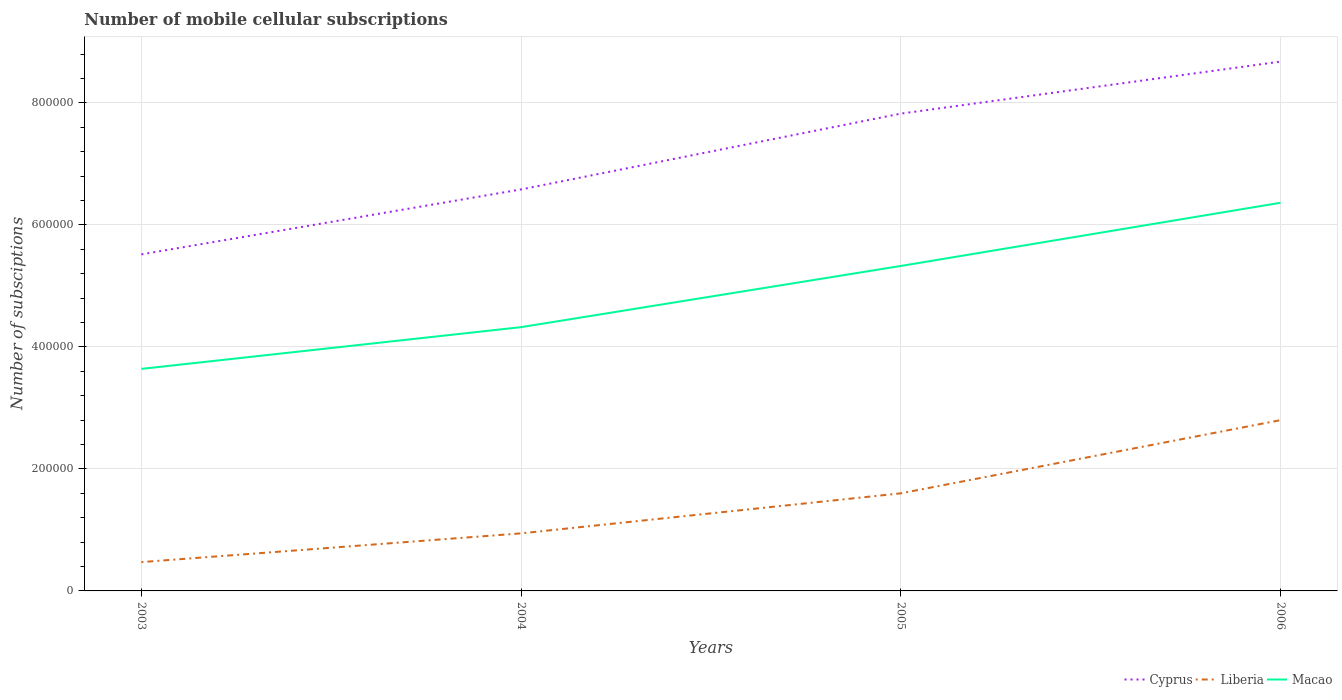How many different coloured lines are there?
Offer a very short reply. 3. Does the line corresponding to Cyprus intersect with the line corresponding to Macao?
Provide a succinct answer. No. Is the number of lines equal to the number of legend labels?
Give a very brief answer. Yes. Across all years, what is the maximum number of mobile cellular subscriptions in Cyprus?
Provide a short and direct response. 5.52e+05. In which year was the number of mobile cellular subscriptions in Macao maximum?
Make the answer very short. 2003. What is the total number of mobile cellular subscriptions in Liberia in the graph?
Give a very brief answer. -4.71e+04. What is the difference between the highest and the second highest number of mobile cellular subscriptions in Liberia?
Keep it short and to the point. 2.33e+05. What is the difference between the highest and the lowest number of mobile cellular subscriptions in Liberia?
Your response must be concise. 2. How many lines are there?
Provide a succinct answer. 3. How many years are there in the graph?
Keep it short and to the point. 4. Are the values on the major ticks of Y-axis written in scientific E-notation?
Your response must be concise. No. Does the graph contain any zero values?
Your answer should be compact. No. How many legend labels are there?
Your answer should be compact. 3. How are the legend labels stacked?
Your answer should be compact. Horizontal. What is the title of the graph?
Your answer should be very brief. Number of mobile cellular subscriptions. What is the label or title of the Y-axis?
Your answer should be very brief. Number of subsciptions. What is the Number of subsciptions of Cyprus in 2003?
Provide a succinct answer. 5.52e+05. What is the Number of subsciptions in Liberia in 2003?
Ensure brevity in your answer.  4.72e+04. What is the Number of subsciptions in Macao in 2003?
Provide a succinct answer. 3.64e+05. What is the Number of subsciptions of Cyprus in 2004?
Keep it short and to the point. 6.58e+05. What is the Number of subsciptions of Liberia in 2004?
Provide a succinct answer. 9.44e+04. What is the Number of subsciptions of Macao in 2004?
Your response must be concise. 4.32e+05. What is the Number of subsciptions of Cyprus in 2005?
Ensure brevity in your answer.  7.83e+05. What is the Number of subsciptions of Macao in 2005?
Your answer should be very brief. 5.33e+05. What is the Number of subsciptions of Cyprus in 2006?
Ensure brevity in your answer.  8.68e+05. What is the Number of subsciptions in Macao in 2006?
Your response must be concise. 6.36e+05. Across all years, what is the maximum Number of subsciptions of Cyprus?
Your answer should be compact. 8.68e+05. Across all years, what is the maximum Number of subsciptions of Liberia?
Your answer should be compact. 2.80e+05. Across all years, what is the maximum Number of subsciptions in Macao?
Make the answer very short. 6.36e+05. Across all years, what is the minimum Number of subsciptions in Cyprus?
Make the answer very short. 5.52e+05. Across all years, what is the minimum Number of subsciptions of Liberia?
Provide a succinct answer. 4.72e+04. Across all years, what is the minimum Number of subsciptions in Macao?
Keep it short and to the point. 3.64e+05. What is the total Number of subsciptions in Cyprus in the graph?
Make the answer very short. 2.86e+06. What is the total Number of subsciptions in Liberia in the graph?
Make the answer very short. 5.82e+05. What is the total Number of subsciptions of Macao in the graph?
Offer a very short reply. 1.97e+06. What is the difference between the Number of subsciptions in Cyprus in 2003 and that in 2004?
Your response must be concise. -1.06e+05. What is the difference between the Number of subsciptions of Liberia in 2003 and that in 2004?
Give a very brief answer. -4.71e+04. What is the difference between the Number of subsciptions of Macao in 2003 and that in 2004?
Ensure brevity in your answer.  -6.84e+04. What is the difference between the Number of subsciptions in Cyprus in 2003 and that in 2005?
Give a very brief answer. -2.31e+05. What is the difference between the Number of subsciptions of Liberia in 2003 and that in 2005?
Give a very brief answer. -1.13e+05. What is the difference between the Number of subsciptions of Macao in 2003 and that in 2005?
Keep it short and to the point. -1.69e+05. What is the difference between the Number of subsciptions in Cyprus in 2003 and that in 2006?
Ensure brevity in your answer.  -3.16e+05. What is the difference between the Number of subsciptions in Liberia in 2003 and that in 2006?
Offer a terse response. -2.33e+05. What is the difference between the Number of subsciptions in Macao in 2003 and that in 2006?
Your response must be concise. -2.72e+05. What is the difference between the Number of subsciptions in Cyprus in 2004 and that in 2005?
Provide a succinct answer. -1.24e+05. What is the difference between the Number of subsciptions of Liberia in 2004 and that in 2005?
Make the answer very short. -6.56e+04. What is the difference between the Number of subsciptions in Macao in 2004 and that in 2005?
Your answer should be very brief. -1.00e+05. What is the difference between the Number of subsciptions in Cyprus in 2004 and that in 2006?
Ensure brevity in your answer.  -2.10e+05. What is the difference between the Number of subsciptions of Liberia in 2004 and that in 2006?
Provide a short and direct response. -1.86e+05. What is the difference between the Number of subsciptions in Macao in 2004 and that in 2006?
Make the answer very short. -2.04e+05. What is the difference between the Number of subsciptions in Cyprus in 2005 and that in 2006?
Your answer should be compact. -8.53e+04. What is the difference between the Number of subsciptions of Macao in 2005 and that in 2006?
Provide a short and direct response. -1.04e+05. What is the difference between the Number of subsciptions in Cyprus in 2003 and the Number of subsciptions in Liberia in 2004?
Make the answer very short. 4.57e+05. What is the difference between the Number of subsciptions in Cyprus in 2003 and the Number of subsciptions in Macao in 2004?
Your answer should be compact. 1.19e+05. What is the difference between the Number of subsciptions in Liberia in 2003 and the Number of subsciptions in Macao in 2004?
Your response must be concise. -3.85e+05. What is the difference between the Number of subsciptions in Cyprus in 2003 and the Number of subsciptions in Liberia in 2005?
Your answer should be compact. 3.92e+05. What is the difference between the Number of subsciptions of Cyprus in 2003 and the Number of subsciptions of Macao in 2005?
Keep it short and to the point. 1.90e+04. What is the difference between the Number of subsciptions in Liberia in 2003 and the Number of subsciptions in Macao in 2005?
Your response must be concise. -4.86e+05. What is the difference between the Number of subsciptions of Cyprus in 2003 and the Number of subsciptions of Liberia in 2006?
Offer a very short reply. 2.72e+05. What is the difference between the Number of subsciptions in Cyprus in 2003 and the Number of subsciptions in Macao in 2006?
Give a very brief answer. -8.46e+04. What is the difference between the Number of subsciptions in Liberia in 2003 and the Number of subsciptions in Macao in 2006?
Give a very brief answer. -5.89e+05. What is the difference between the Number of subsciptions of Cyprus in 2004 and the Number of subsciptions of Liberia in 2005?
Your response must be concise. 4.98e+05. What is the difference between the Number of subsciptions of Cyprus in 2004 and the Number of subsciptions of Macao in 2005?
Your answer should be compact. 1.25e+05. What is the difference between the Number of subsciptions in Liberia in 2004 and the Number of subsciptions in Macao in 2005?
Your answer should be compact. -4.38e+05. What is the difference between the Number of subsciptions in Cyprus in 2004 and the Number of subsciptions in Liberia in 2006?
Ensure brevity in your answer.  3.78e+05. What is the difference between the Number of subsciptions of Cyprus in 2004 and the Number of subsciptions of Macao in 2006?
Your answer should be very brief. 2.19e+04. What is the difference between the Number of subsciptions in Liberia in 2004 and the Number of subsciptions in Macao in 2006?
Provide a short and direct response. -5.42e+05. What is the difference between the Number of subsciptions in Cyprus in 2005 and the Number of subsciptions in Liberia in 2006?
Ensure brevity in your answer.  5.03e+05. What is the difference between the Number of subsciptions of Cyprus in 2005 and the Number of subsciptions of Macao in 2006?
Offer a very short reply. 1.46e+05. What is the difference between the Number of subsciptions in Liberia in 2005 and the Number of subsciptions in Macao in 2006?
Provide a short and direct response. -4.76e+05. What is the average Number of subsciptions in Cyprus per year?
Your answer should be compact. 7.15e+05. What is the average Number of subsciptions in Liberia per year?
Your answer should be very brief. 1.45e+05. What is the average Number of subsciptions in Macao per year?
Give a very brief answer. 4.91e+05. In the year 2003, what is the difference between the Number of subsciptions of Cyprus and Number of subsciptions of Liberia?
Ensure brevity in your answer.  5.05e+05. In the year 2003, what is the difference between the Number of subsciptions in Cyprus and Number of subsciptions in Macao?
Offer a very short reply. 1.88e+05. In the year 2003, what is the difference between the Number of subsciptions of Liberia and Number of subsciptions of Macao?
Make the answer very short. -3.17e+05. In the year 2004, what is the difference between the Number of subsciptions in Cyprus and Number of subsciptions in Liberia?
Your answer should be very brief. 5.64e+05. In the year 2004, what is the difference between the Number of subsciptions in Cyprus and Number of subsciptions in Macao?
Make the answer very short. 2.26e+05. In the year 2004, what is the difference between the Number of subsciptions in Liberia and Number of subsciptions in Macao?
Offer a very short reply. -3.38e+05. In the year 2005, what is the difference between the Number of subsciptions in Cyprus and Number of subsciptions in Liberia?
Your answer should be compact. 6.23e+05. In the year 2005, what is the difference between the Number of subsciptions of Cyprus and Number of subsciptions of Macao?
Provide a short and direct response. 2.50e+05. In the year 2005, what is the difference between the Number of subsciptions in Liberia and Number of subsciptions in Macao?
Give a very brief answer. -3.73e+05. In the year 2006, what is the difference between the Number of subsciptions in Cyprus and Number of subsciptions in Liberia?
Provide a short and direct response. 5.88e+05. In the year 2006, what is the difference between the Number of subsciptions of Cyprus and Number of subsciptions of Macao?
Give a very brief answer. 2.31e+05. In the year 2006, what is the difference between the Number of subsciptions in Liberia and Number of subsciptions in Macao?
Offer a very short reply. -3.56e+05. What is the ratio of the Number of subsciptions of Cyprus in 2003 to that in 2004?
Your response must be concise. 0.84. What is the ratio of the Number of subsciptions in Liberia in 2003 to that in 2004?
Your answer should be compact. 0.5. What is the ratio of the Number of subsciptions in Macao in 2003 to that in 2004?
Your response must be concise. 0.84. What is the ratio of the Number of subsciptions in Cyprus in 2003 to that in 2005?
Offer a very short reply. 0.71. What is the ratio of the Number of subsciptions in Liberia in 2003 to that in 2005?
Make the answer very short. 0.3. What is the ratio of the Number of subsciptions in Macao in 2003 to that in 2005?
Ensure brevity in your answer.  0.68. What is the ratio of the Number of subsciptions of Cyprus in 2003 to that in 2006?
Your answer should be compact. 0.64. What is the ratio of the Number of subsciptions of Liberia in 2003 to that in 2006?
Ensure brevity in your answer.  0.17. What is the ratio of the Number of subsciptions of Macao in 2003 to that in 2006?
Ensure brevity in your answer.  0.57. What is the ratio of the Number of subsciptions of Cyprus in 2004 to that in 2005?
Give a very brief answer. 0.84. What is the ratio of the Number of subsciptions in Liberia in 2004 to that in 2005?
Offer a very short reply. 0.59. What is the ratio of the Number of subsciptions in Macao in 2004 to that in 2005?
Provide a succinct answer. 0.81. What is the ratio of the Number of subsciptions in Cyprus in 2004 to that in 2006?
Provide a short and direct response. 0.76. What is the ratio of the Number of subsciptions in Liberia in 2004 to that in 2006?
Provide a succinct answer. 0.34. What is the ratio of the Number of subsciptions in Macao in 2004 to that in 2006?
Your answer should be compact. 0.68. What is the ratio of the Number of subsciptions of Cyprus in 2005 to that in 2006?
Provide a short and direct response. 0.9. What is the ratio of the Number of subsciptions in Macao in 2005 to that in 2006?
Provide a succinct answer. 0.84. What is the difference between the highest and the second highest Number of subsciptions of Cyprus?
Offer a terse response. 8.53e+04. What is the difference between the highest and the second highest Number of subsciptions in Macao?
Offer a very short reply. 1.04e+05. What is the difference between the highest and the lowest Number of subsciptions in Cyprus?
Keep it short and to the point. 3.16e+05. What is the difference between the highest and the lowest Number of subsciptions of Liberia?
Ensure brevity in your answer.  2.33e+05. What is the difference between the highest and the lowest Number of subsciptions of Macao?
Your answer should be very brief. 2.72e+05. 